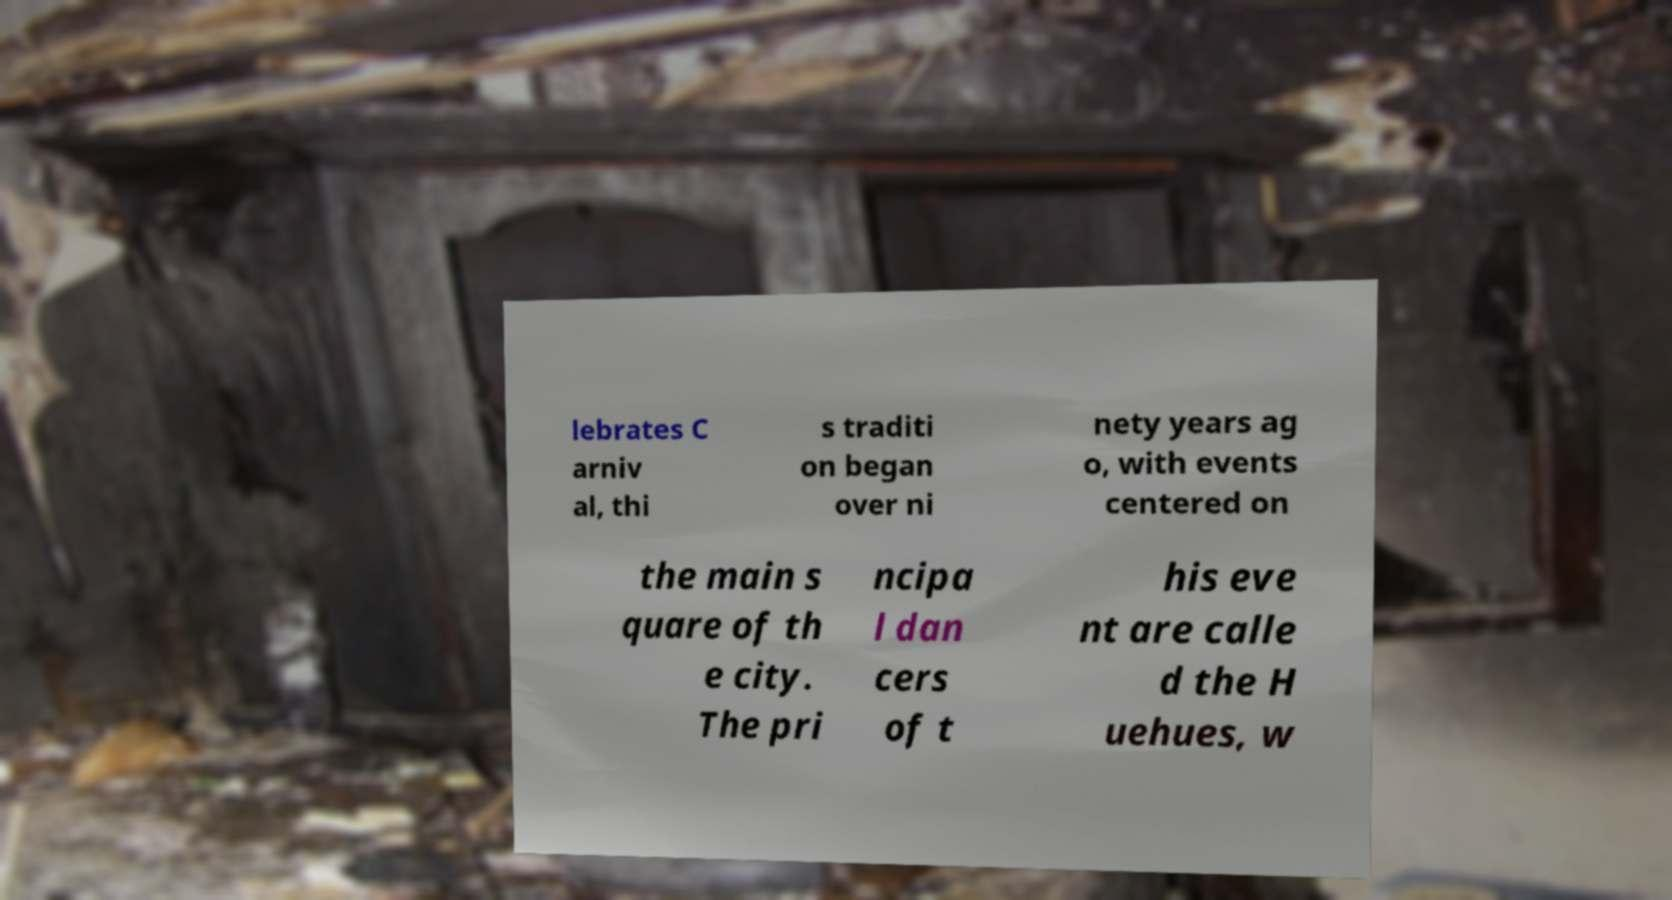Could you extract and type out the text from this image? lebrates C arniv al, thi s traditi on began over ni nety years ag o, with events centered on the main s quare of th e city. The pri ncipa l dan cers of t his eve nt are calle d the H uehues, w 